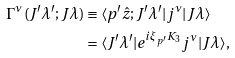Convert formula to latex. <formula><loc_0><loc_0><loc_500><loc_500>\Gamma ^ { \nu } ( J ^ { \prime } \lambda ^ { \prime } ; J \lambda ) & \equiv \langle p ^ { \prime } \hat { z } ; J ^ { \prime } \lambda ^ { \prime } | j ^ { \nu } | J \lambda \rangle \\ & = \langle J ^ { \prime } \lambda ^ { \prime } | e ^ { i \xi _ { p ^ { \prime } } K _ { 3 } } j ^ { \nu } | J \lambda \rangle ,</formula> 